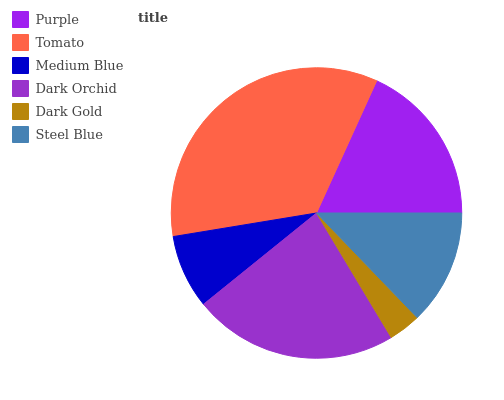Is Dark Gold the minimum?
Answer yes or no. Yes. Is Tomato the maximum?
Answer yes or no. Yes. Is Medium Blue the minimum?
Answer yes or no. No. Is Medium Blue the maximum?
Answer yes or no. No. Is Tomato greater than Medium Blue?
Answer yes or no. Yes. Is Medium Blue less than Tomato?
Answer yes or no. Yes. Is Medium Blue greater than Tomato?
Answer yes or no. No. Is Tomato less than Medium Blue?
Answer yes or no. No. Is Purple the high median?
Answer yes or no. Yes. Is Steel Blue the low median?
Answer yes or no. Yes. Is Tomato the high median?
Answer yes or no. No. Is Dark Orchid the low median?
Answer yes or no. No. 